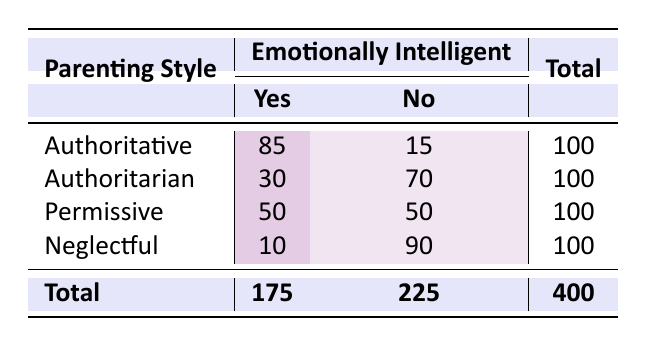What is the count of children raised by Authoritative parents who are emotionally intelligent? From the table, look under the "Authoritative" row and the "Yes" column. The count is 85, indicating that 85 children raised with this style are emotionally intelligent.
Answer: 85 How many children raised in a Neglectful parenting style are not emotionally intelligent? Under the "Neglectful" row and the "No" column, the count is 90. This shows that 90 children raised in this style are not emotionally intelligent.
Answer: 90 What is the total number of children raised by Permissive parents? To find the total, sum the values in the "Permissive" row: 50 (Yes) + 50 (No) = 100. Therefore, 100 children were raised by Permissive parents.
Answer: 100 Which parenting style had the highest number of emotionally intelligent children? Looking at the "Yes" column, Authoritative has 85, Authoritarian has 30, Permissive has 50, and Neglectful has 10. Authoritative has the highest number, which is 85.
Answer: Authoritative What percentage of children raised Authoritarian are emotionally intelligent? In the Authoritarian row, the total children are 100. The number who are emotionally intelligent is 30. Calculate the percentage: (30/100) * 100 = 30%.
Answer: 30% How many more children raised in a Neglectful style are not emotionally intelligent compared to those raised Authoritative? For Neglectful, there are 90 children not emotionally intelligent. For Authoritative, there are 15. The difference is 90 - 15 = 75.
Answer: 75 Is it true that Permissive parenting style has more emotionally intelligent than Authoritarian style? Yes, Permissive has 50, while Authoritarian has 30. Thus, Permissive has more emotionally intelligent children.
Answer: Yes What is the total number of emotionally intelligent children across all parenting styles? Sum the "Yes" column: 85 (Authoritative) + 30 (Authoritarian) + 50 (Permissive) + 10 (Neglectful) = 175. Therefore, the total is 175.
Answer: 175 If a child is raised in an Authoritarian style, what are their chances of being emotionally intelligent? There are 30 emotionally intelligent children out of a total of 100 raised Authoritarian. The chances are 30%, calculated as (30/100) * 100.
Answer: 30% 